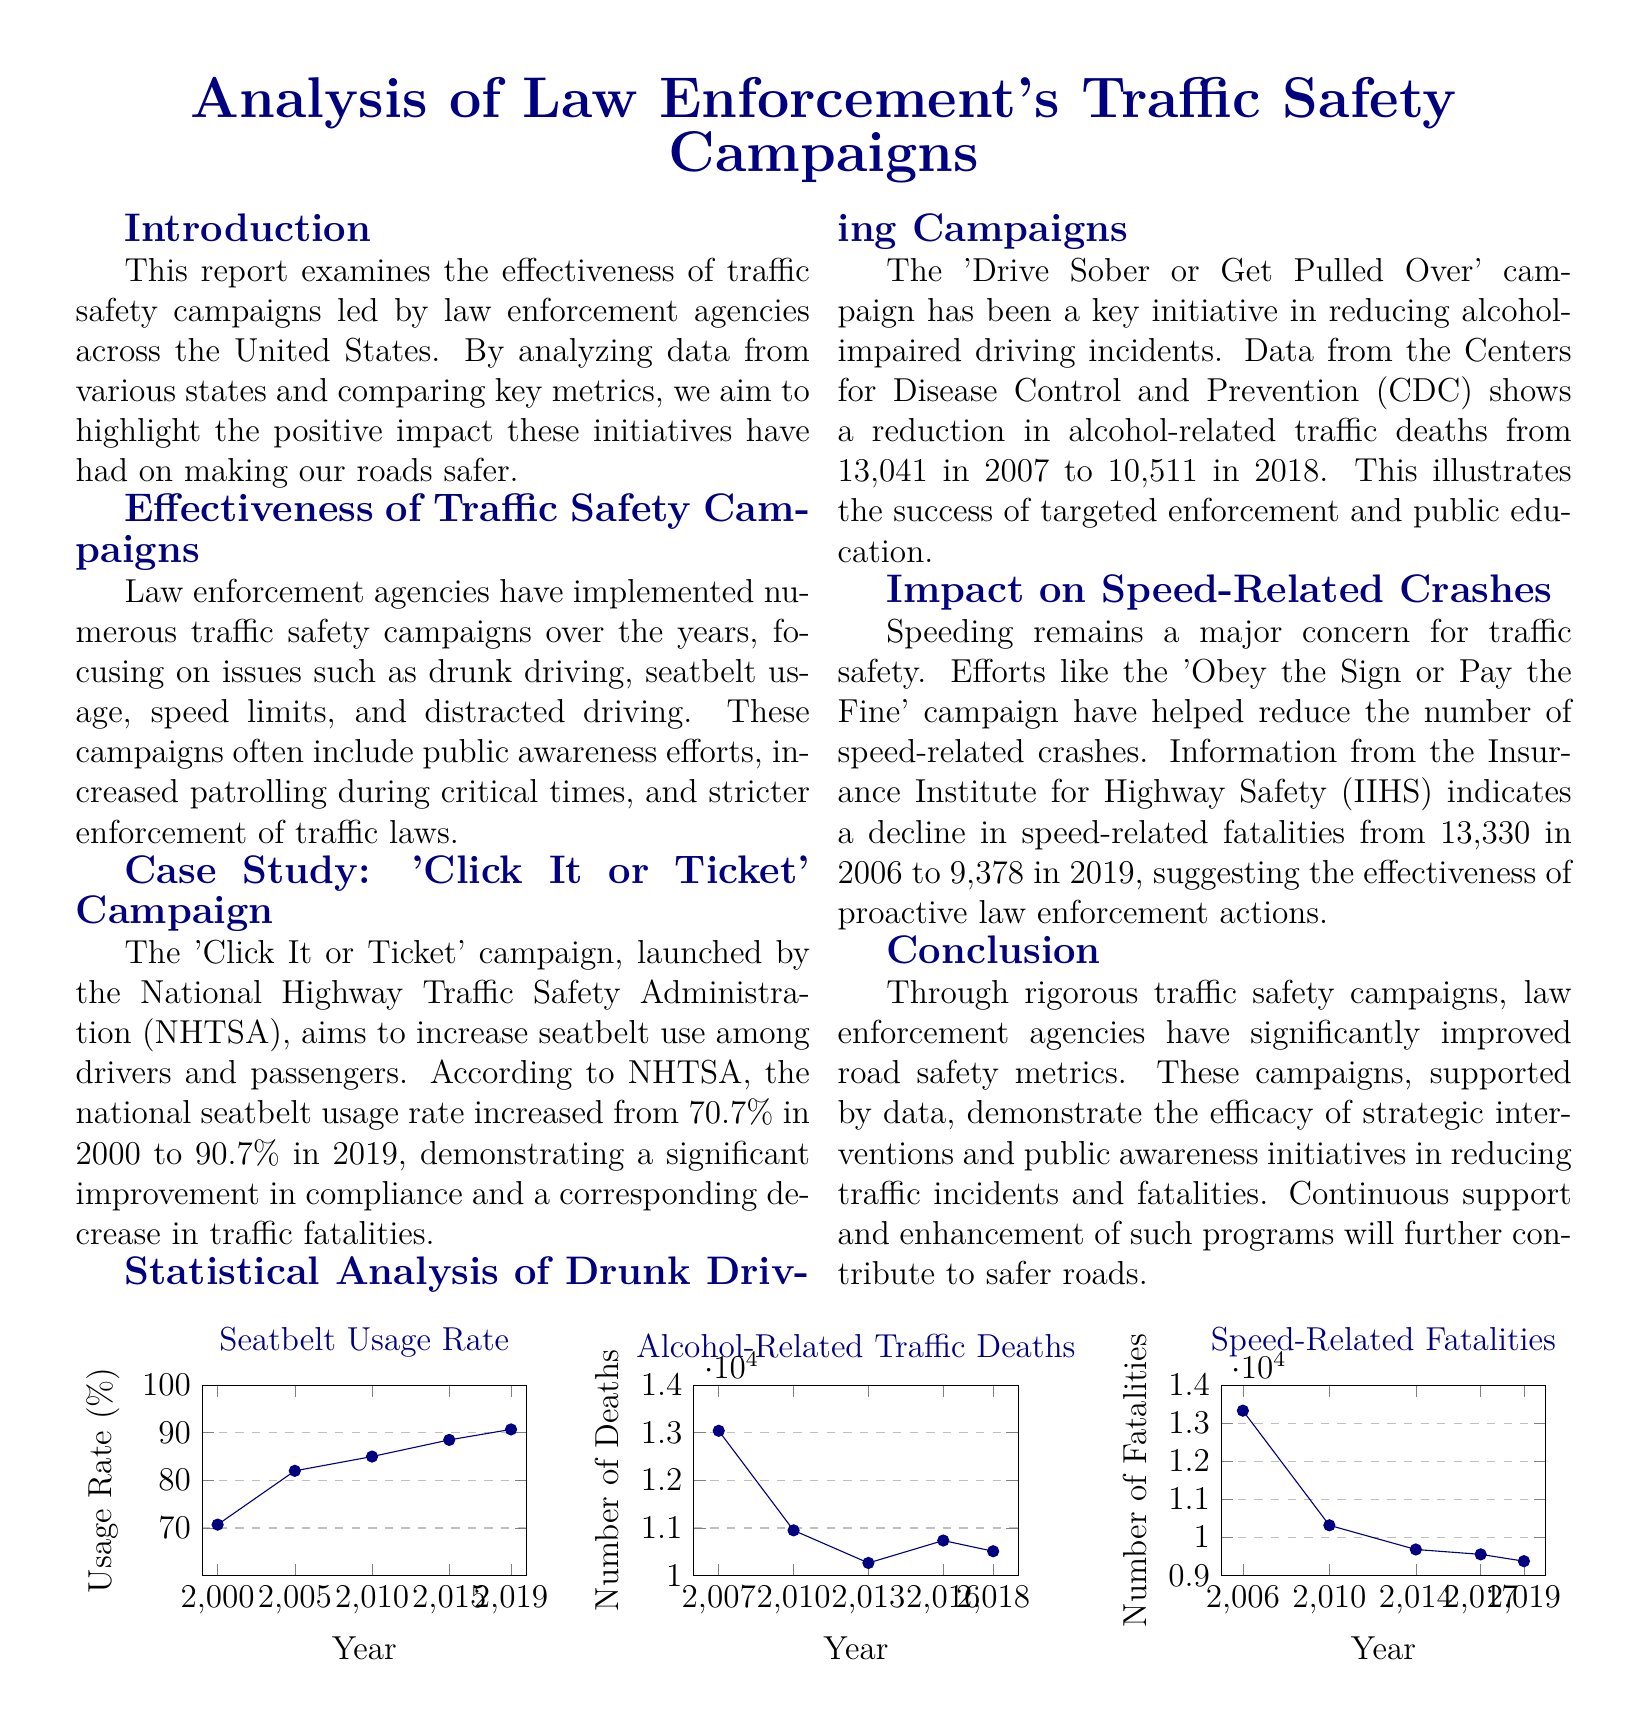what is the national seatbelt usage rate in 2019? The national seatbelt usage rate increased to 90.7% in 2019 according to the document.
Answer: 90.7% how many alcohol-related traffic deaths were reported in 2007? The number of alcohol-related traffic deaths reported in 2007 was 13,041, as noted in the statistical analysis section.
Answer: 13,041 what specific campaign aimed to reduce alcohol-impaired driving incidents? The document identifies the 'Drive Sober or Get Pulled Over' campaign as a key initiative for reducing alcohol-related incidents.
Answer: Drive Sober or Get Pulled Over from which year to which year does the seatbelt usage rate data range? The seatbelt usage rate data spans from the year 2000 to 2019, as shown in the visual statistics.
Answer: 2000 to 2019 how did the number of speed-related fatalities change from 2006 to 2019? The document indicates a decline in speed-related fatalities from 13,330 in 2006 to 9,378 in 2019, demonstrating a positive trend.
Answer: Decline what overall impact did law enforcement's traffic safety campaigns have on road safety metrics? Law enforcement's traffic safety campaigns have significantly improved road safety metrics, as summarized in the conclusion.
Answer: Improved what is the title of the case study highlighted in the report? The case study highlighted is titled 'Click It or Ticket' campaign, focusing on seatbelt usage.
Answer: Click It or Ticket what was the number of alcohol-related deaths in 2018? The number of alcohol-related traffic deaths reported in 2018 was 10,511 according to the document.
Answer: 10,511 